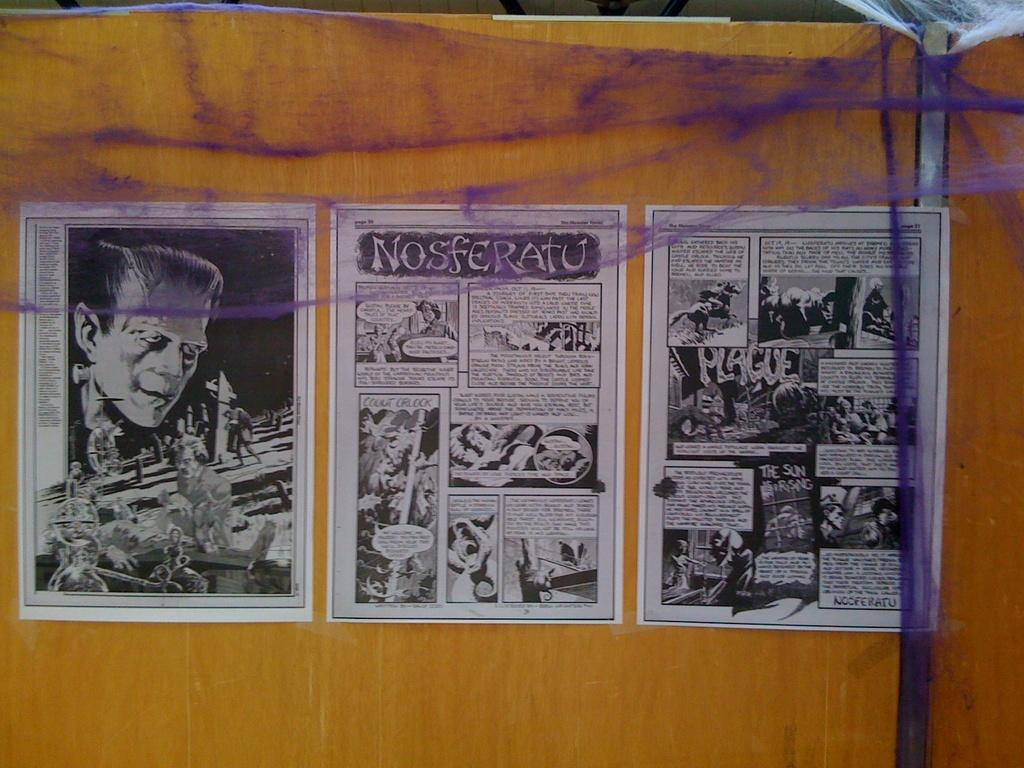<image>
Write a terse but informative summary of the picture. Drawings featuring Frankenstein say Nosferatu at the top. 